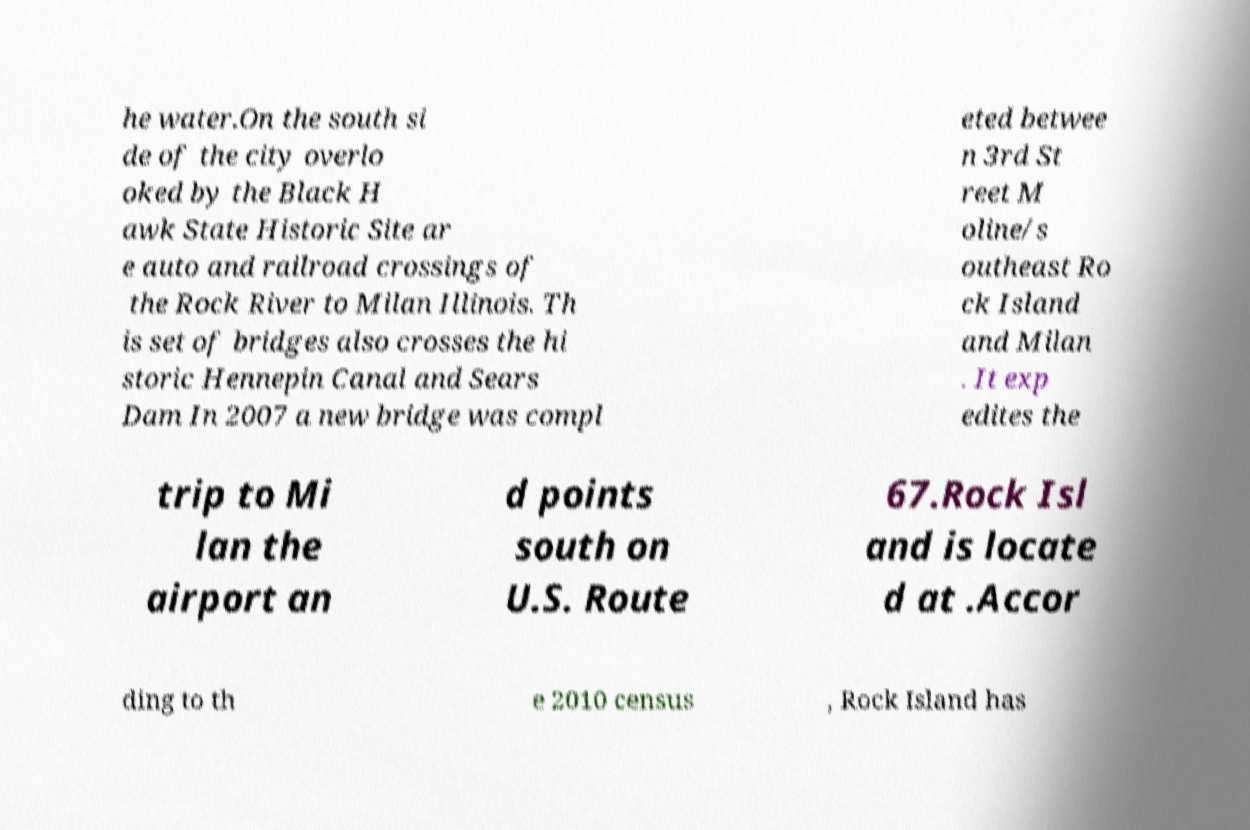There's text embedded in this image that I need extracted. Can you transcribe it verbatim? he water.On the south si de of the city overlo oked by the Black H awk State Historic Site ar e auto and railroad crossings of the Rock River to Milan Illinois. Th is set of bridges also crosses the hi storic Hennepin Canal and Sears Dam In 2007 a new bridge was compl eted betwee n 3rd St reet M oline/s outheast Ro ck Island and Milan . It exp edites the trip to Mi lan the airport an d points south on U.S. Route 67.Rock Isl and is locate d at .Accor ding to th e 2010 census , Rock Island has 